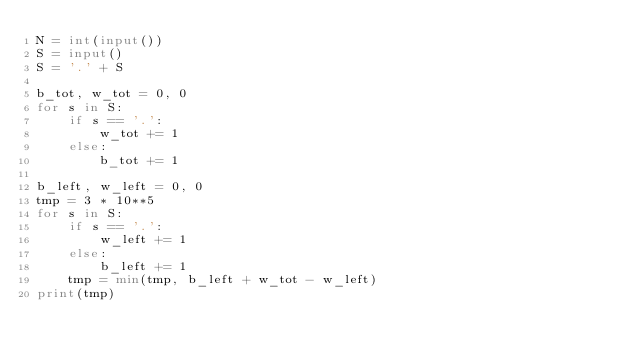Convert code to text. <code><loc_0><loc_0><loc_500><loc_500><_Python_>N = int(input())
S = input()
S = '.' + S

b_tot, w_tot = 0, 0
for s in S:
    if s == '.':
        w_tot += 1
    else:
        b_tot += 1

b_left, w_left = 0, 0
tmp = 3 * 10**5
for s in S:
    if s == '.':
        w_left += 1
    else:
        b_left += 1
    tmp = min(tmp, b_left + w_tot - w_left)
print(tmp)</code> 